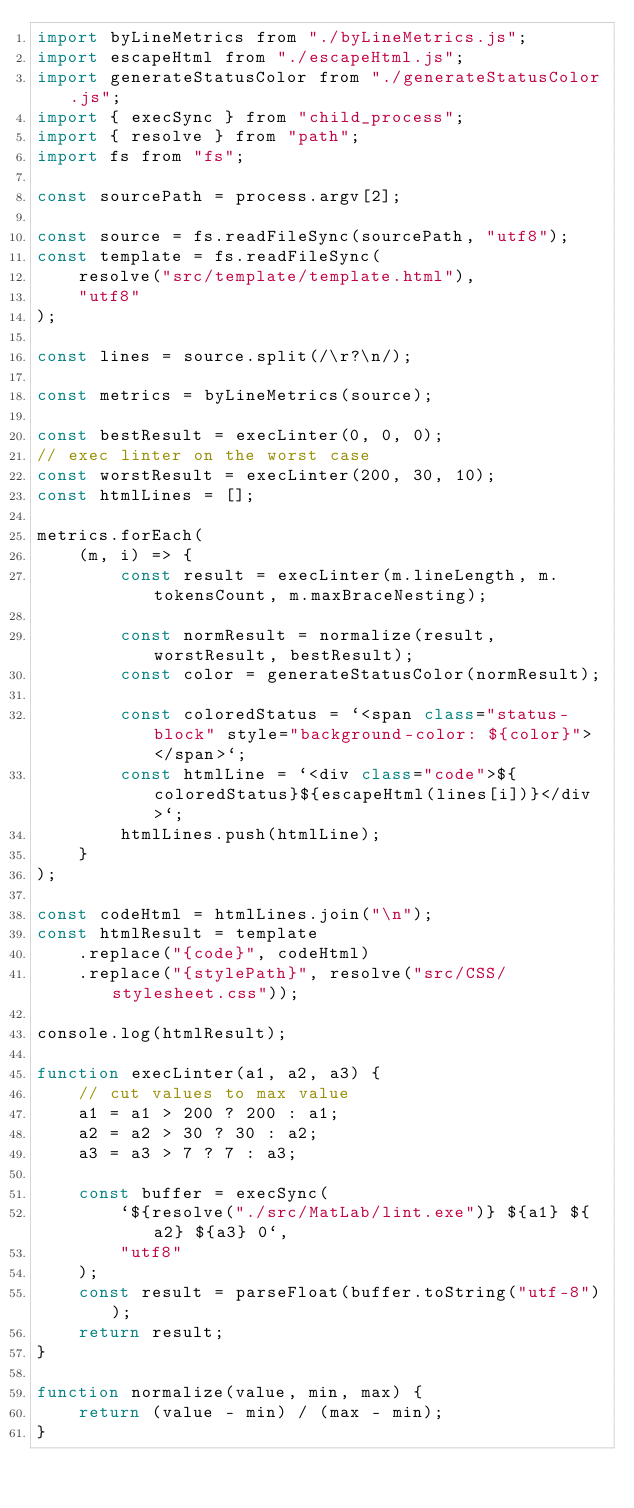<code> <loc_0><loc_0><loc_500><loc_500><_JavaScript_>import byLineMetrics from "./byLineMetrics.js";
import escapeHtml from "./escapeHtml.js";
import generateStatusColor from "./generateStatusColor.js";
import { execSync } from "child_process";
import { resolve } from "path";
import fs from "fs";

const sourcePath = process.argv[2];

const source = fs.readFileSync(sourcePath, "utf8");
const template = fs.readFileSync(
    resolve("src/template/template.html"),
    "utf8"
);

const lines = source.split(/\r?\n/);

const metrics = byLineMetrics(source);

const bestResult = execLinter(0, 0, 0);
// exec linter on the worst case
const worstResult = execLinter(200, 30, 10);
const htmlLines = [];

metrics.forEach(
    (m, i) => {
        const result = execLinter(m.lineLength, m.tokensCount, m.maxBraceNesting);

        const normResult = normalize(result, worstResult, bestResult);
        const color = generateStatusColor(normResult);

        const coloredStatus = `<span class="status-block" style="background-color: ${color}"> </span>`;
        const htmlLine = `<div class="code">${coloredStatus}${escapeHtml(lines[i])}</div>`;
        htmlLines.push(htmlLine);
    }
);

const codeHtml = htmlLines.join("\n");
const htmlResult = template
    .replace("{code}", codeHtml)
    .replace("{stylePath}", resolve("src/CSS/stylesheet.css"));

console.log(htmlResult);

function execLinter(a1, a2, a3) {
    // cut values to max value
    a1 = a1 > 200 ? 200 : a1;
    a2 = a2 > 30 ? 30 : a2;
    a3 = a3 > 7 ? 7 : a3;
    
    const buffer = execSync(
        `${resolve("./src/MatLab/lint.exe")} ${a1} ${a2} ${a3} 0`,
        "utf8"
    );
    const result = parseFloat(buffer.toString("utf-8"));
    return result;
}

function normalize(value, min, max) {
    return (value - min) / (max - min);
}</code> 